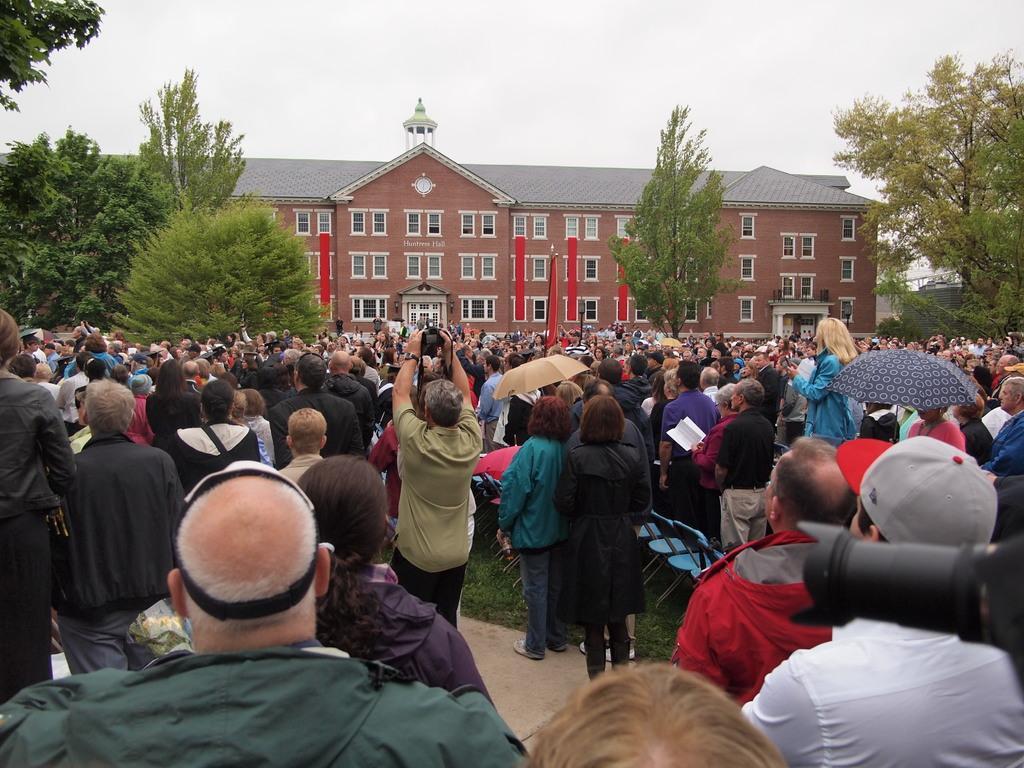Please provide a concise description of this image. In this image there are group of persons standing. On the right side there is a person standing and holding an umbrella. In the background there are trees and there is a building and the sky is cloudy. 